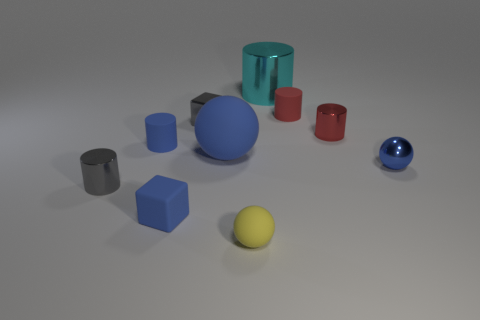Can you describe the shapes and the arrangement of the objects in the image? The image features a collection of geometric shapes arranged on a flat surface. At the forefront, there's a small gray cylinder, and behind it, we see a larger blue sphere. Alongside the blue sphere, there are a medium-sized teal cylinder and a small red cylinder. To the right, there's a smaller blue sphere with a reflective surface, and on the left is a cube, followed by a yellow sphere. The objects seem to be placed randomly, each isolated from the others without touching. 